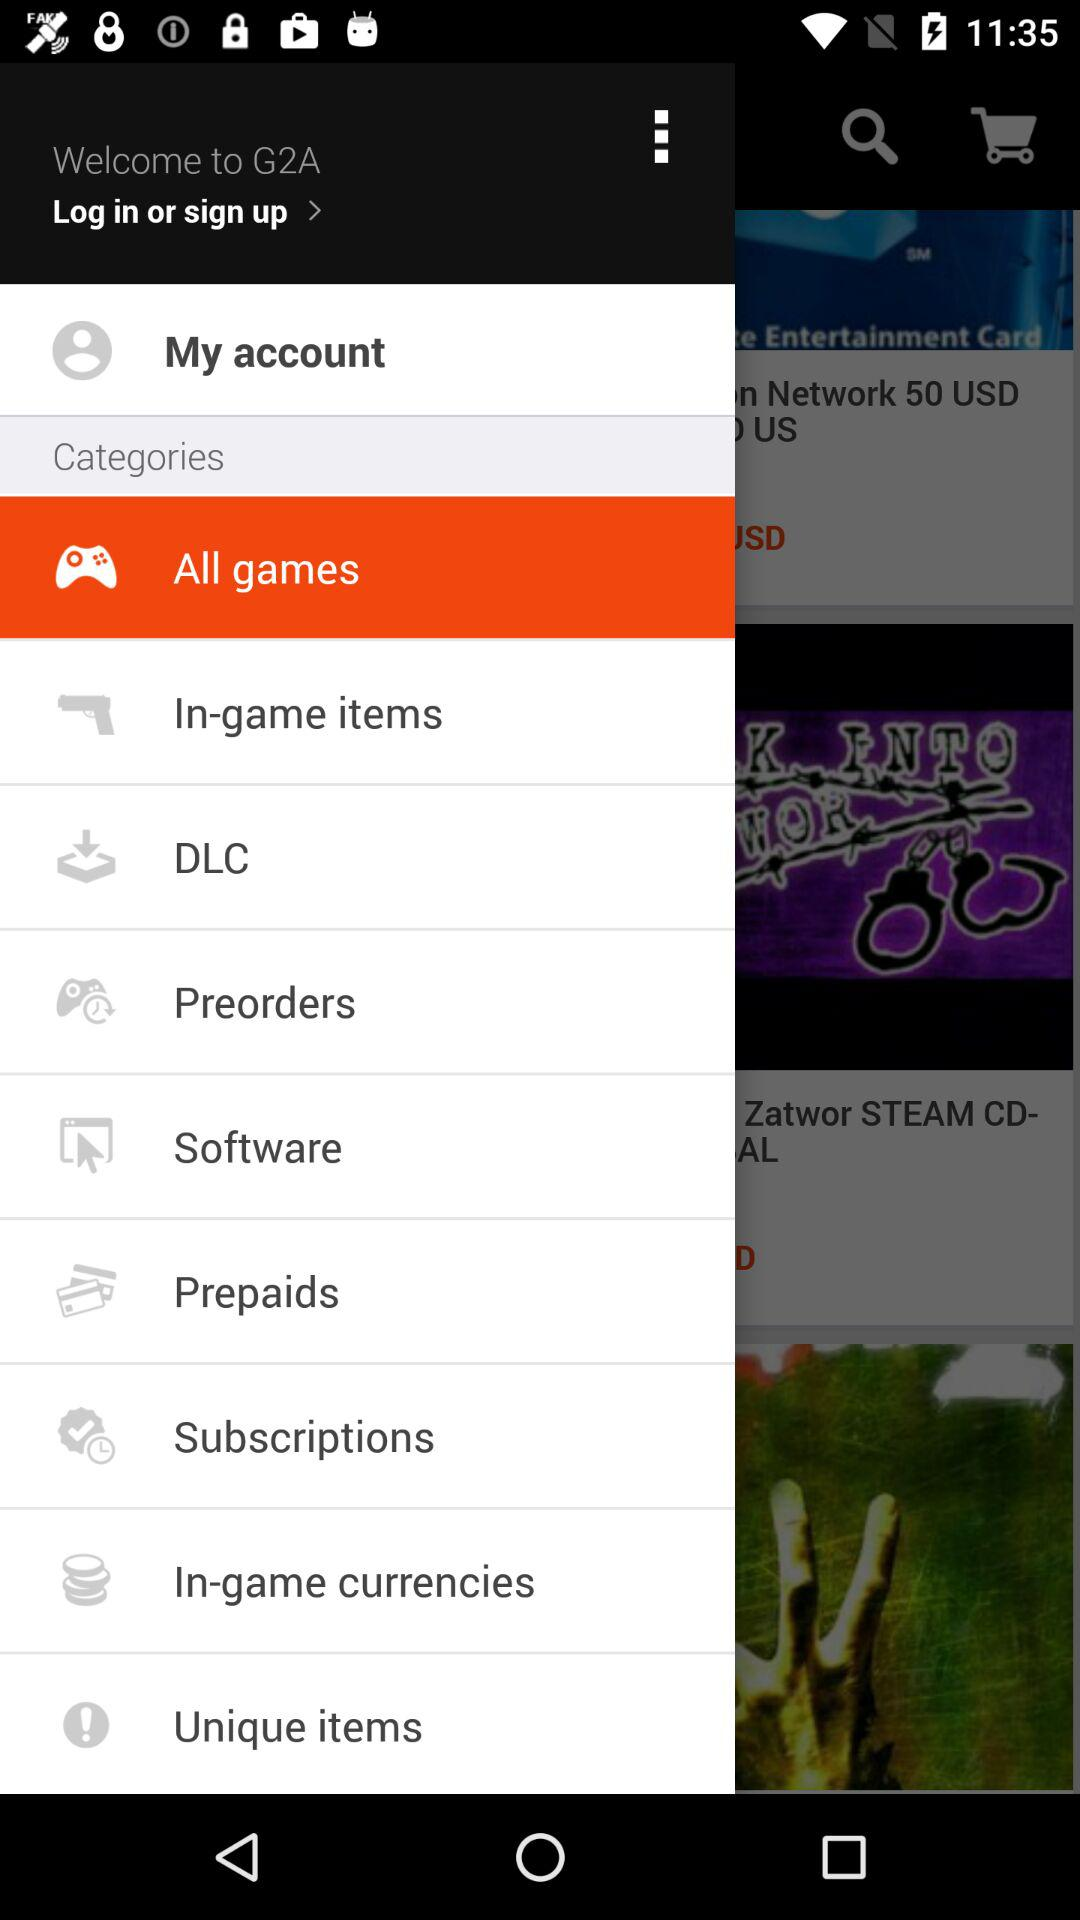How many pre-orders are there?
When the provided information is insufficient, respond with <no answer>. <no answer> 